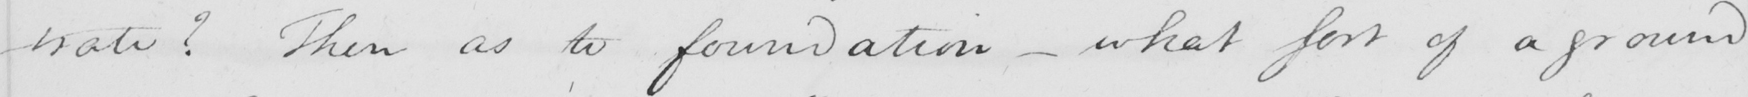Please transcribe the handwritten text in this image. -trate  ?  Then as to foundation  _  what sort of a ground 